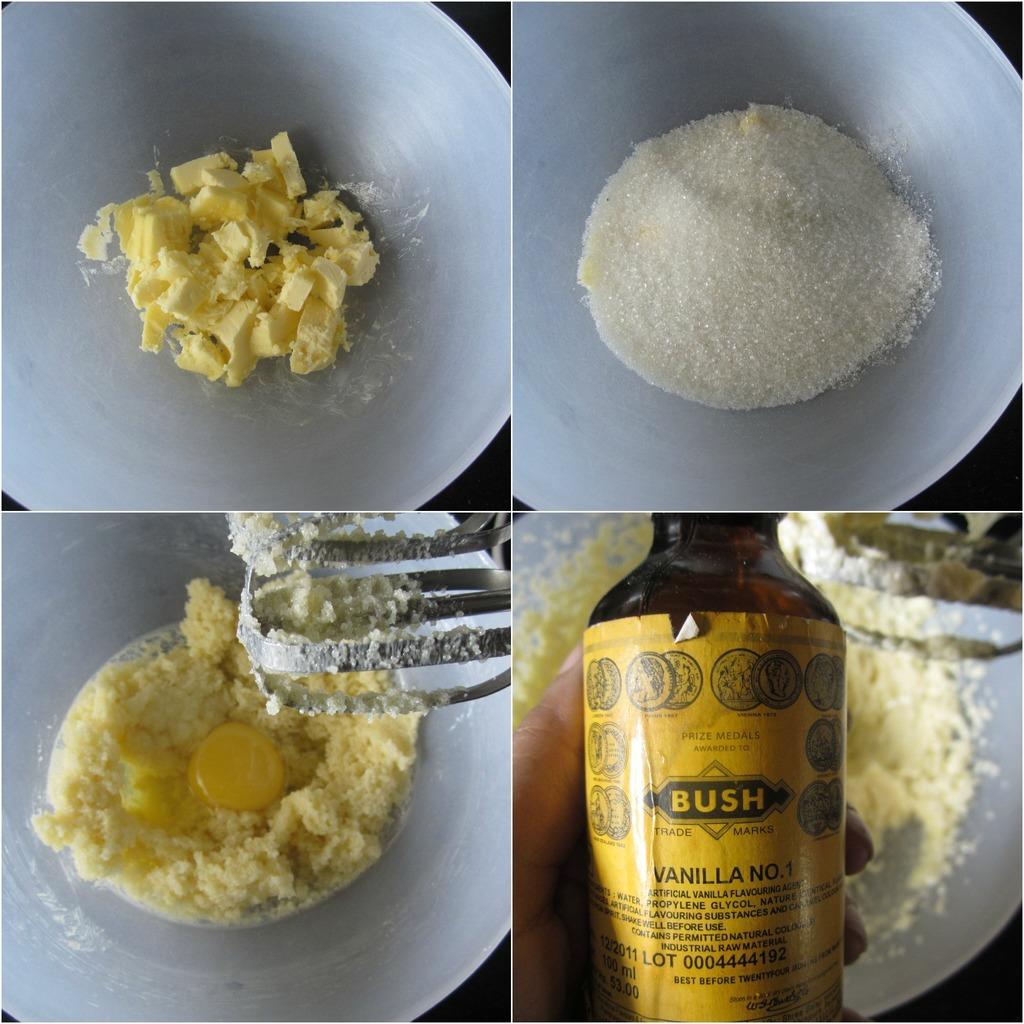What is the volume of this bottle?
Provide a succinct answer. 100 ml. 